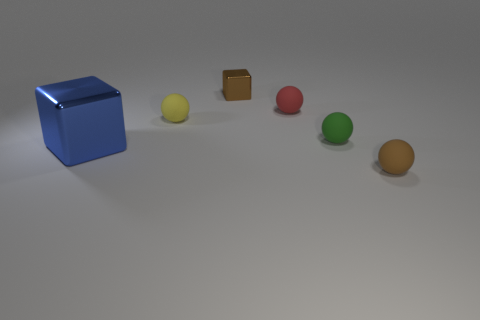Subtract 1 balls. How many balls are left? 3 Add 3 big rubber objects. How many objects exist? 9 Subtract all spheres. How many objects are left? 2 Subtract all small yellow objects. Subtract all blocks. How many objects are left? 3 Add 3 red rubber balls. How many red rubber balls are left? 4 Add 2 small brown metal cubes. How many small brown metal cubes exist? 3 Subtract 0 yellow blocks. How many objects are left? 6 